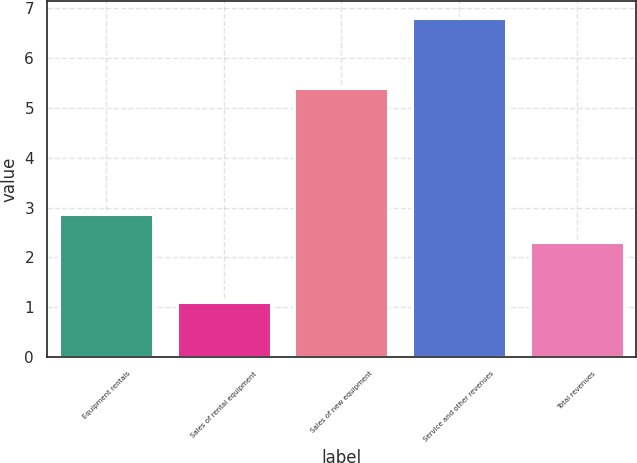Convert chart. <chart><loc_0><loc_0><loc_500><loc_500><bar_chart><fcel>Equipment rentals<fcel>Sales of rental equipment<fcel>Sales of new equipment<fcel>Service and other revenues<fcel>Total revenues<nl><fcel>2.87<fcel>1.1<fcel>5.4<fcel>6.8<fcel>2.3<nl></chart> 